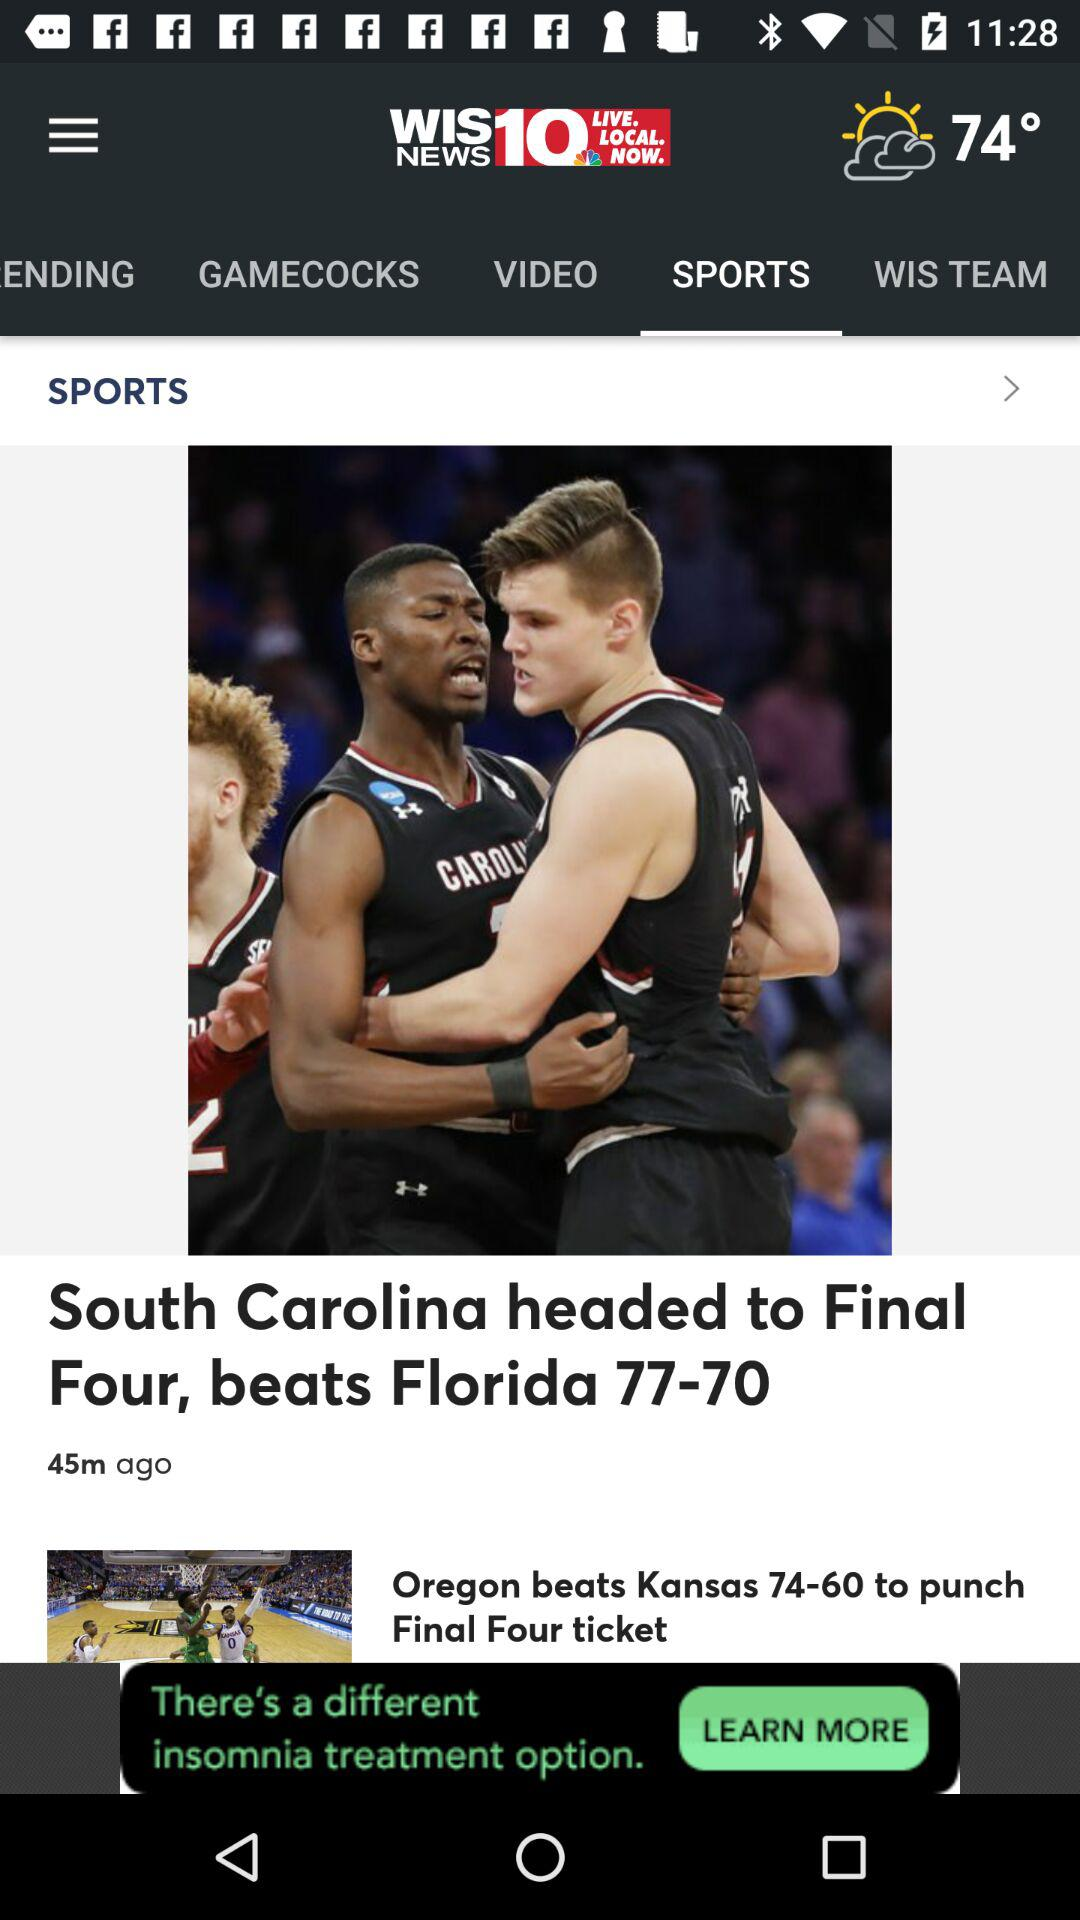Which tab is selected? The selected tab is "SPORTS". 